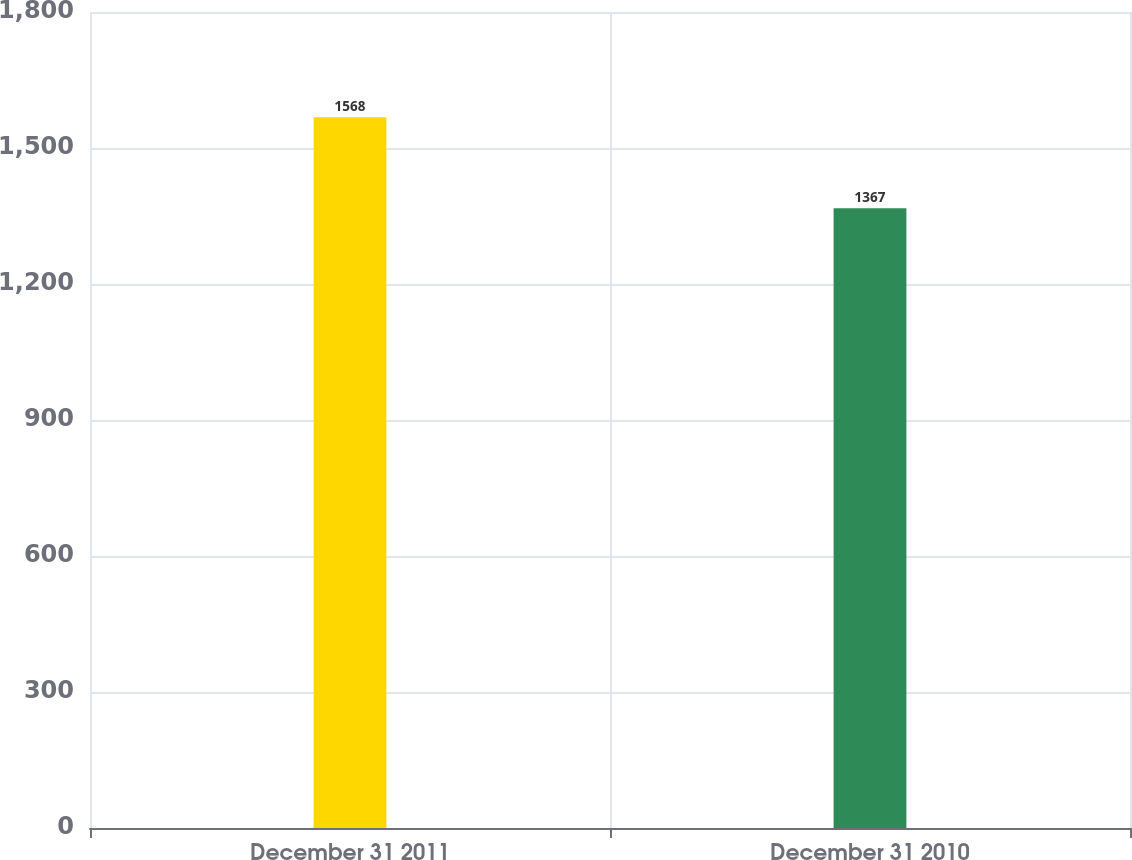<chart> <loc_0><loc_0><loc_500><loc_500><bar_chart><fcel>December 31 2011<fcel>December 31 2010<nl><fcel>1568<fcel>1367<nl></chart> 